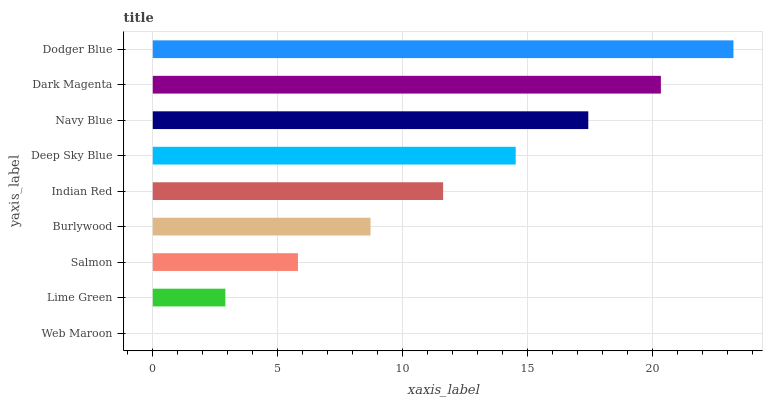Is Web Maroon the minimum?
Answer yes or no. Yes. Is Dodger Blue the maximum?
Answer yes or no. Yes. Is Lime Green the minimum?
Answer yes or no. No. Is Lime Green the maximum?
Answer yes or no. No. Is Lime Green greater than Web Maroon?
Answer yes or no. Yes. Is Web Maroon less than Lime Green?
Answer yes or no. Yes. Is Web Maroon greater than Lime Green?
Answer yes or no. No. Is Lime Green less than Web Maroon?
Answer yes or no. No. Is Indian Red the high median?
Answer yes or no. Yes. Is Indian Red the low median?
Answer yes or no. Yes. Is Lime Green the high median?
Answer yes or no. No. Is Dodger Blue the low median?
Answer yes or no. No. 